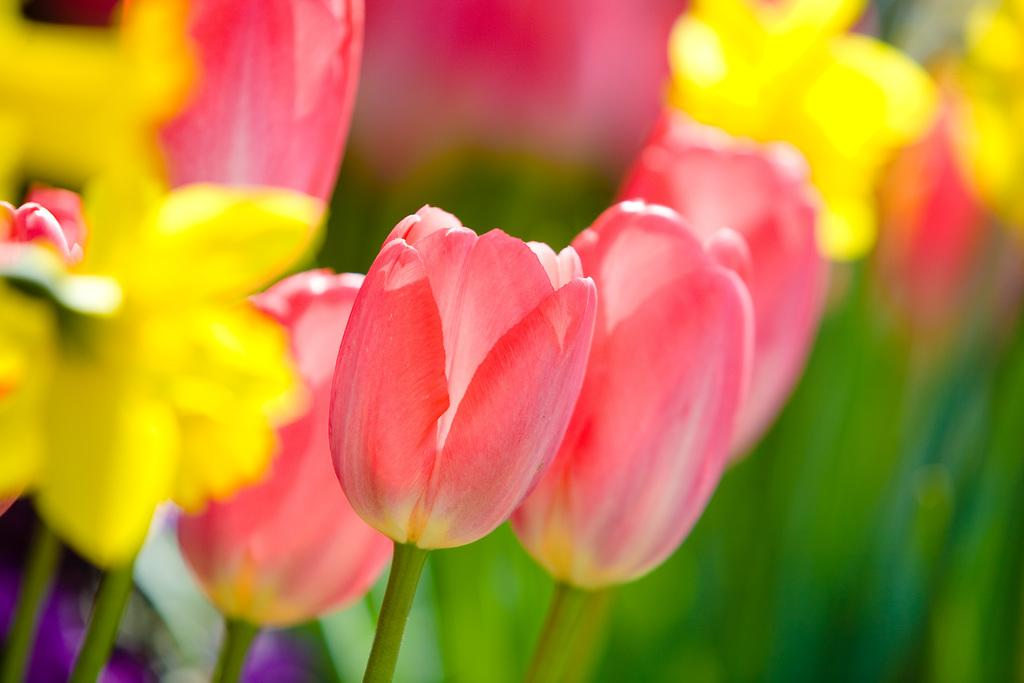What type of flowers are present in the image? There are tulips in the image. How many tulips can be seen in the image? The number of tulips is not specified, but there are tulips present. What is the color of the tulips in the image? The color of the tulips is not mentioned in the facts provided. What type of bomb is being diffused in the image? There is no bomb present in the image; it features tulips. How does the brother's haircut look in the image? There is no brother or haircut present in the image; it features tulips. 